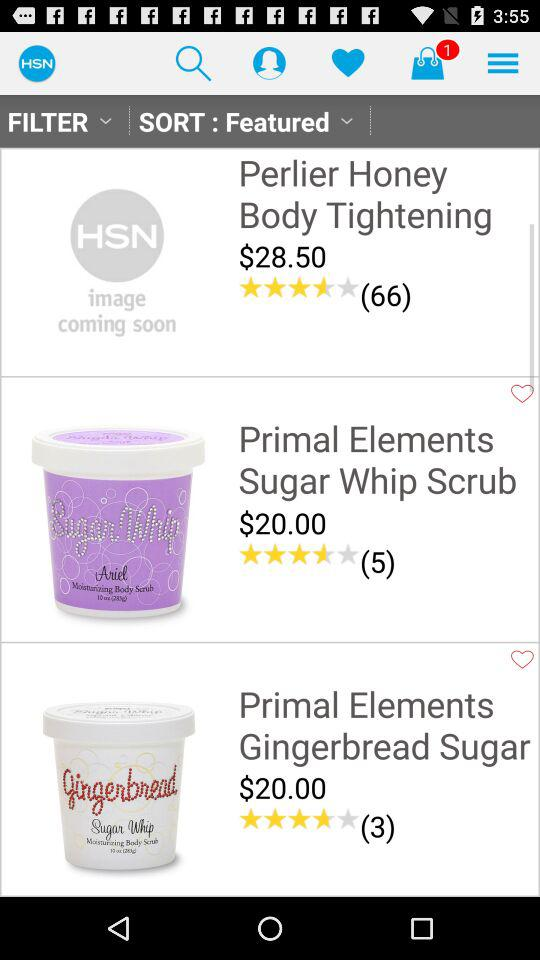How many people have reviewed the "Primal Elements Sugar Whip Scrub"? The number of people is 5. 